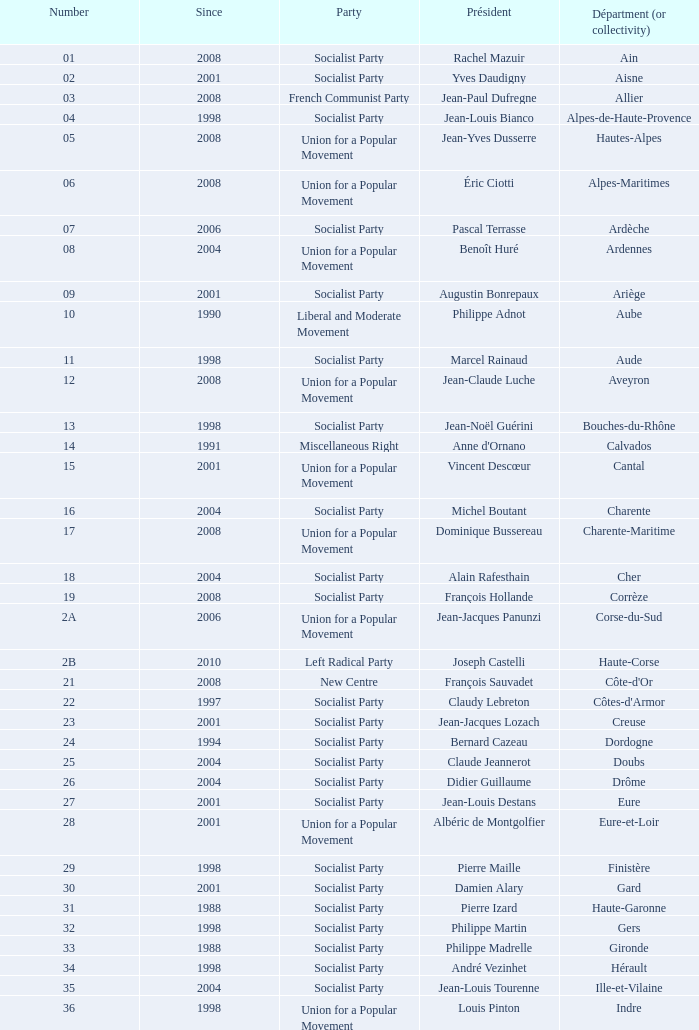What number corresponds to Presidet Yves Krattinger of the Socialist party? 70.0. 